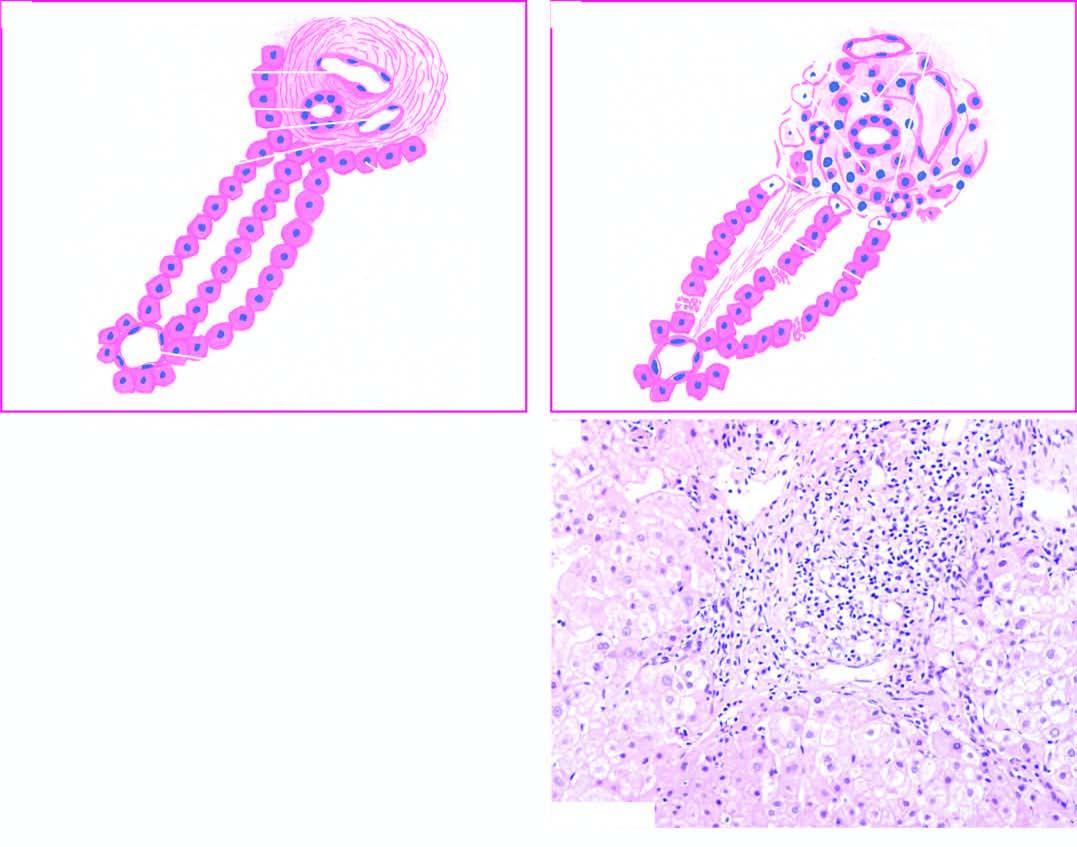what is expanded due to increased lymphomononuclear inflammatory cells which are seen to breach the limiting plate?
Answer the question using a single word or phrase. Portal tract 